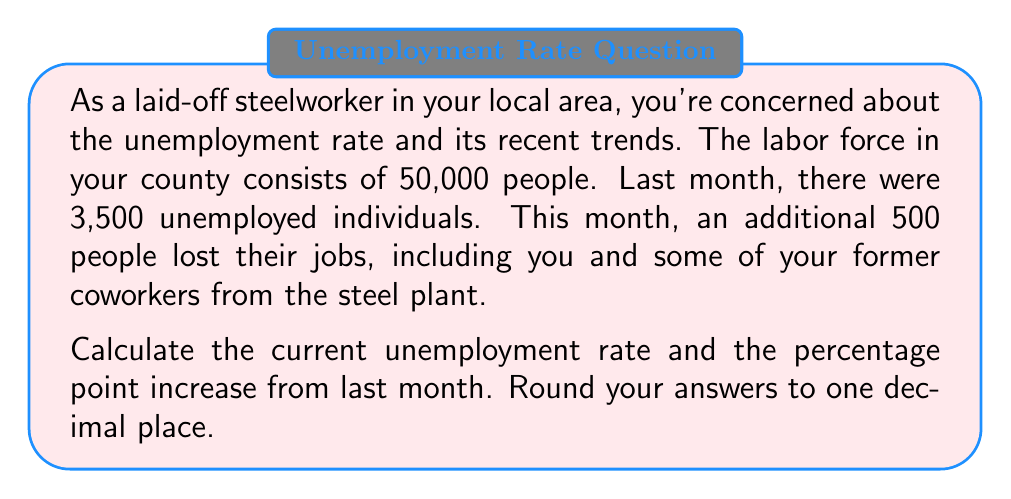Can you answer this question? To solve this problem, we'll follow these steps:

1. Calculate last month's unemployment rate
2. Calculate this month's unemployment rate
3. Find the percentage point increase

Step 1: Last month's unemployment rate
The unemployment rate is calculated by dividing the number of unemployed individuals by the total labor force and multiplying by 100.

$$ \text{Unemployment Rate} = \frac{\text{Number of Unemployed}}{\text{Total Labor Force}} \times 100 $$

Last month's unemployment rate:
$$ \text{Last Month Rate} = \frac{3,500}{50,000} \times 100 = 7\% $$

Step 2: This month's unemployment rate
This month, an additional 500 people became unemployed. So the new number of unemployed is 3,500 + 500 = 4,000.

$$ \text{This Month Rate} = \frac{4,000}{50,000} \times 100 = 8\% $$

Step 3: Percentage point increase
To find the percentage point increase, we simply subtract the old rate from the new rate:

$$ \text{Percentage Point Increase} = 8\% - 7\% = 1\% $$

Both the current unemployment rate and the percentage point increase round to one decimal place as 8.0% and 1.0% respectively.
Answer: Current unemployment rate: 8.0%
Percentage point increase: 1.0 percentage points 